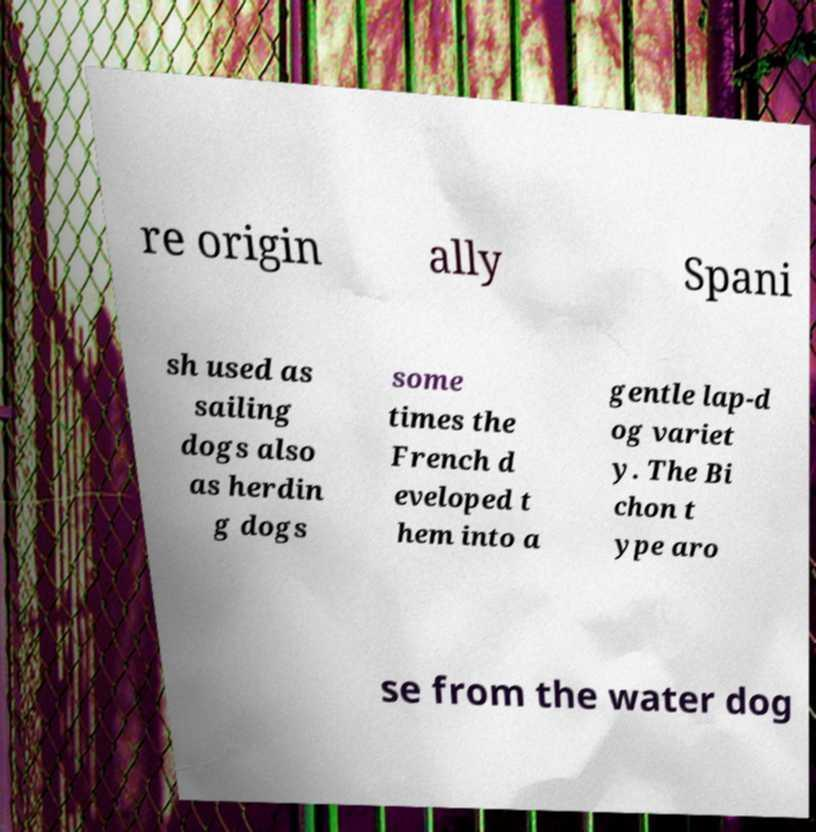Can you accurately transcribe the text from the provided image for me? re origin ally Spani sh used as sailing dogs also as herdin g dogs some times the French d eveloped t hem into a gentle lap-d og variet y. The Bi chon t ype aro se from the water dog 